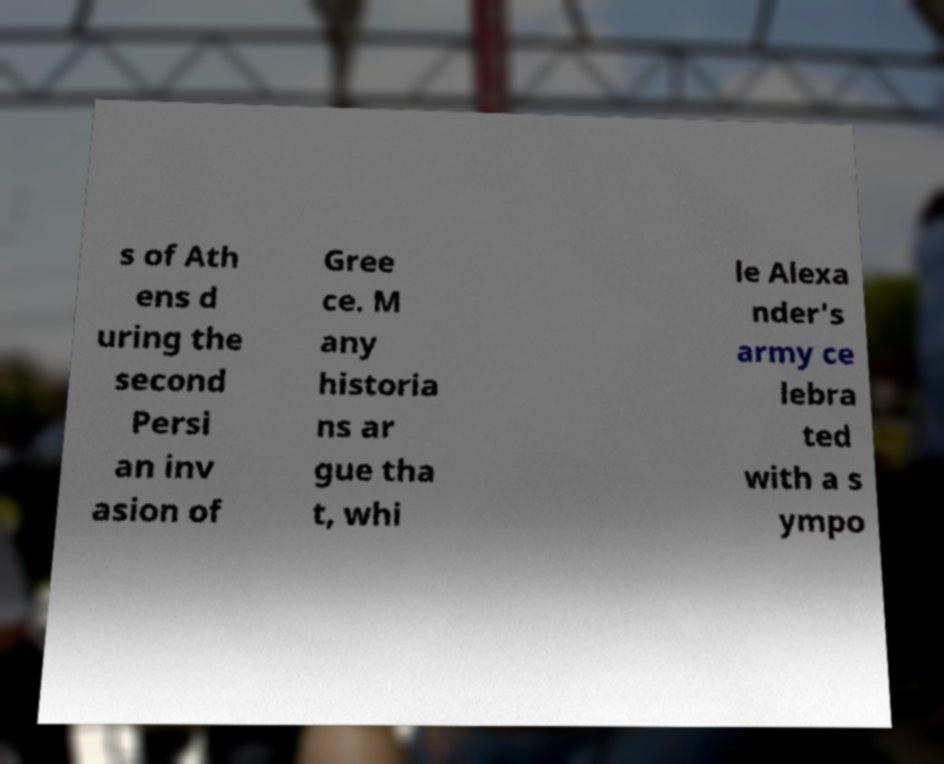Can you accurately transcribe the text from the provided image for me? s of Ath ens d uring the second Persi an inv asion of Gree ce. M any historia ns ar gue tha t, whi le Alexa nder's army ce lebra ted with a s ympo 